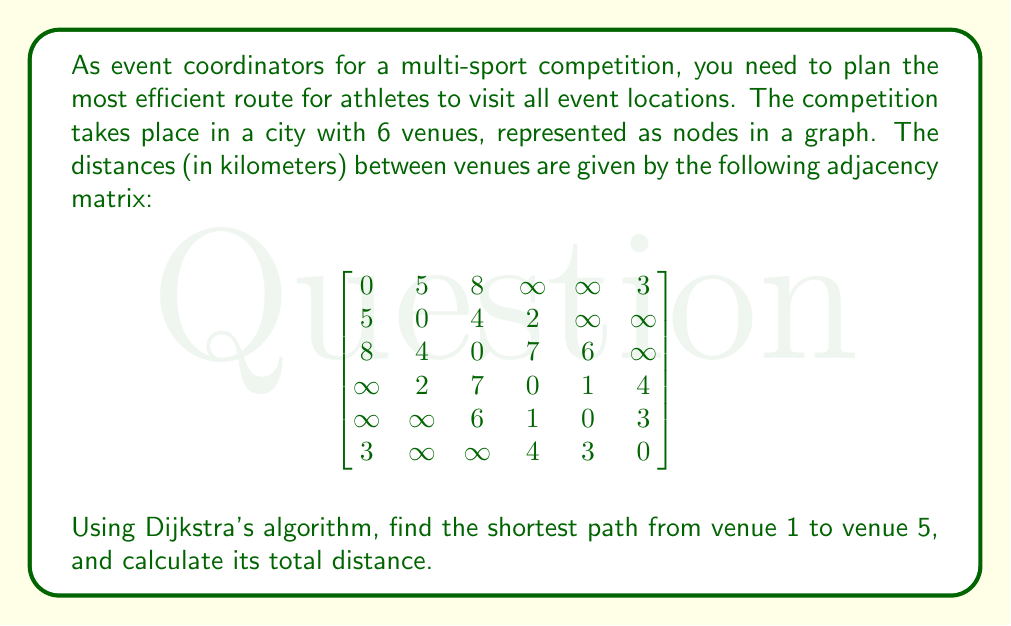Provide a solution to this math problem. To solve this problem, we'll apply Dijkstra's algorithm to find the shortest path from venue 1 to venue 5. Here's a step-by-step explanation:

1) Initialize:
   - Set distance to venue 1 (starting point) as 0
   - Set distances to all other venues as infinity
   - Set all venues as unvisited

2) For the current venue (starting with venue 1), consider all unvisited neighbors and calculate their tentative distances.

3) When we've considered all neighbors of the current venue, mark it as visited. A visited venue will not be checked again.

4) If the destination venue (venue 5) has been marked visited, we're done.

5) Otherwise, select the unvisited venue with the smallest tentative distance, and set it as the new current venue. Go back to step 2.

Let's apply the algorithm:

- Start at venue 1: distance = 0
- Neighbors of 1: 2 (5km), 3 (8km), 6 (3km)
- Mark 1 as visited

- Current vertex: 6 (smallest distance from 1)
- Neighbors of 6: 4 (3+4=7km), 5 (3+3=6km)
- Mark 6 as visited

- Current vertex: 2 (5km from 1)
- Neighbors of 2: 3 (5+4=9km), 4 (5+2=7km)
- Mark 2 as visited

- Current vertex: 5 (6km from 1 via 6)
- Destination reached

The shortest path is 1 -> 6 -> 5, with a total distance of 6km.
Answer: The shortest path from venue 1 to venue 5 is 1 -> 6 -> 5, with a total distance of 6 km. 